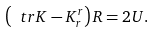<formula> <loc_0><loc_0><loc_500><loc_500>\left ( \ t r K - K ^ { r } _ { r } \right ) R = 2 U .</formula> 